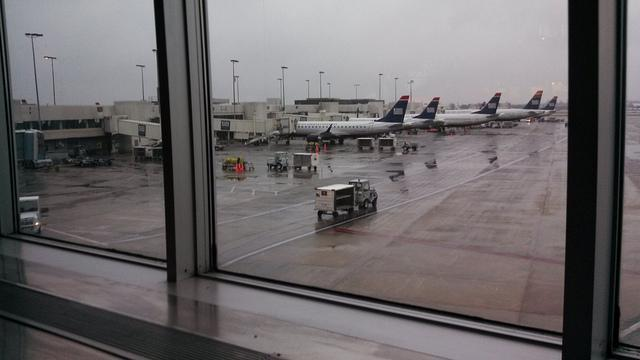What would be the most likely cause of a travel delay for this airport? Please explain your reasoning. clouds. The clouds might make for a foggy flight. 